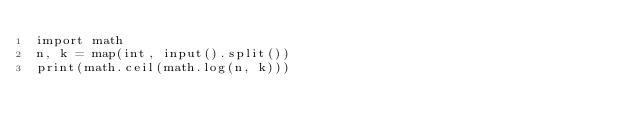Convert code to text. <code><loc_0><loc_0><loc_500><loc_500><_Python_>import math
n, k = map(int, input().split())
print(math.ceil(math.log(n, k)))
</code> 